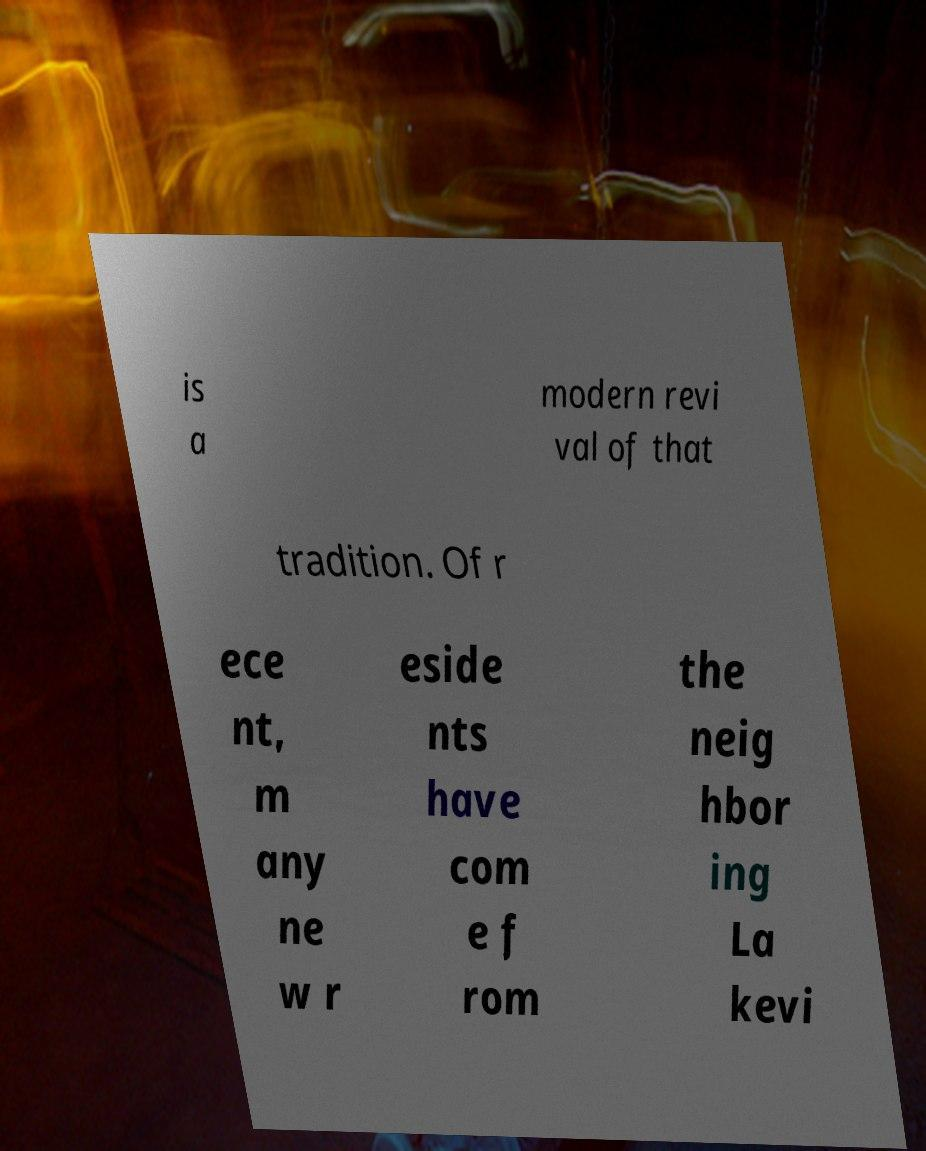Please identify and transcribe the text found in this image. is a modern revi val of that tradition. Of r ece nt, m any ne w r eside nts have com e f rom the neig hbor ing La kevi 